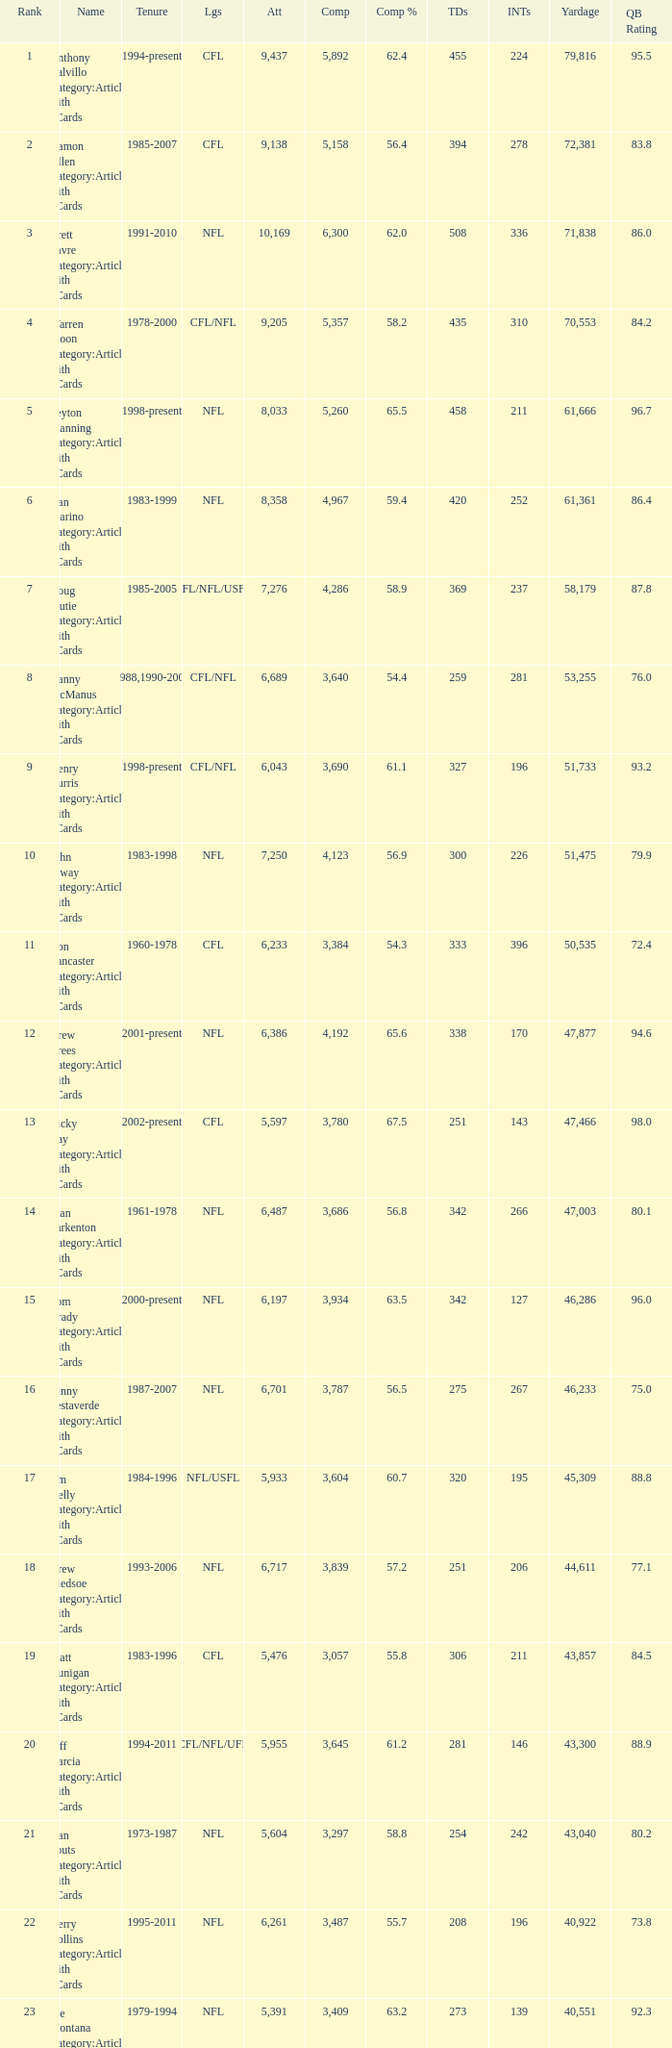What is the number of interceptions with less than 3,487 completions , more than 40,551 yardage, and the comp % is 55.8? 211.0. 